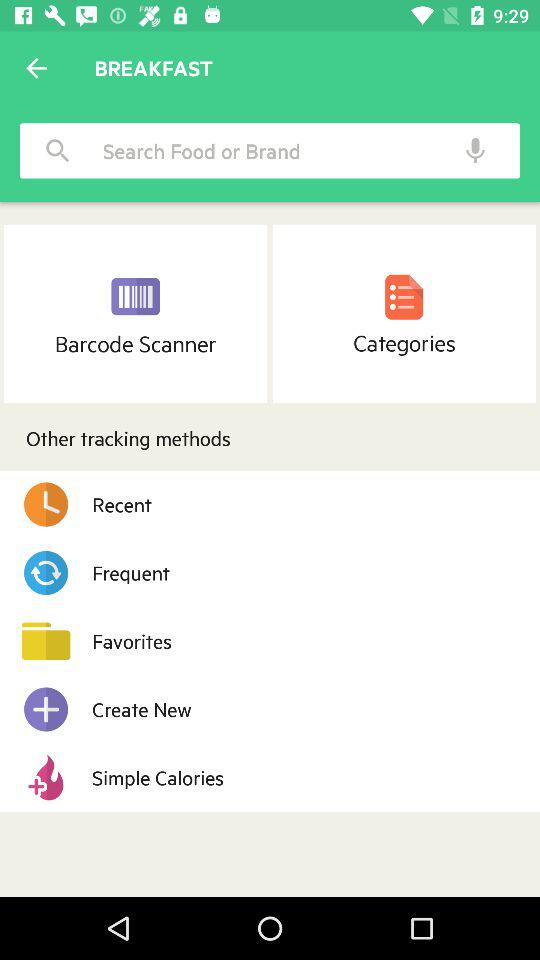What are the other tracking methods we can use? The other tracking methods are "Recent", "Frequent", "Favorites", "Create New" and "Simple Calories". 